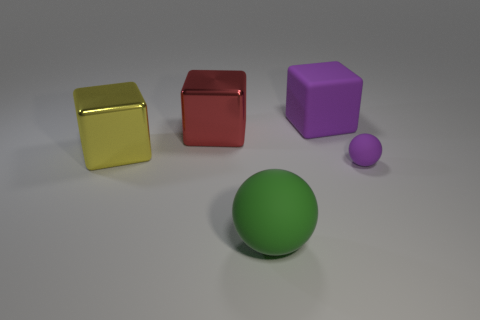Can you tell me the colors of the objects in the image? Certainly! In the image, there's a green ball, a purple cube, a red cube, and a yellow cube. There's also a smaller spherical object that appears to be purple. 